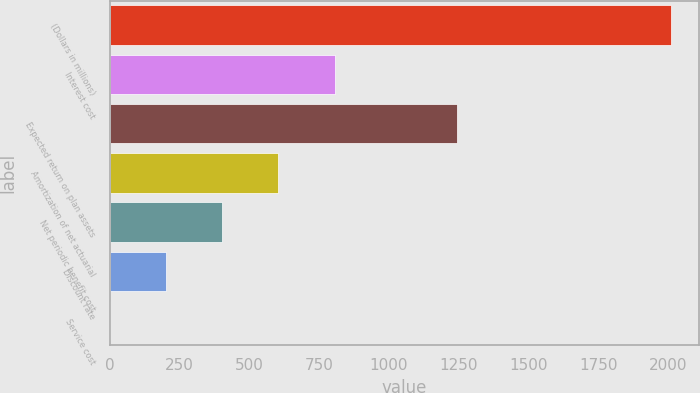Convert chart. <chart><loc_0><loc_0><loc_500><loc_500><bar_chart><fcel>(Dollars in millions)<fcel>Interest cost<fcel>Expected return on plan assets<fcel>Amortization of net actuarial<fcel>Net periodic benefit cost<fcel>Discount rate<fcel>Service cost<nl><fcel>2012<fcel>805.4<fcel>1246<fcel>604.3<fcel>403.2<fcel>202.1<fcel>1<nl></chart> 